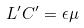<formula> <loc_0><loc_0><loc_500><loc_500>L ^ { \prime } C ^ { \prime } = \epsilon \mu</formula> 